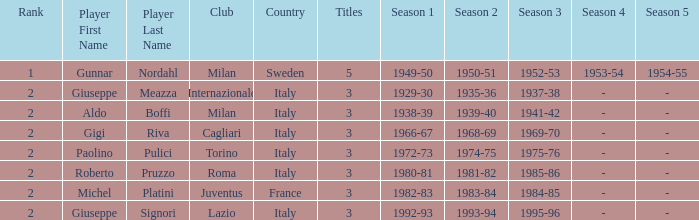What player is ranked 2 and played in the seasons of 1982–83, 1983–84, 1984–85? Michel Platini. 